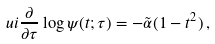<formula> <loc_0><loc_0><loc_500><loc_500>\ u i \frac { \partial } { \partial \tau } \log \psi ( t ; \tau ) = - \tilde { \alpha } ( 1 - t ^ { 2 } ) \, ,</formula> 